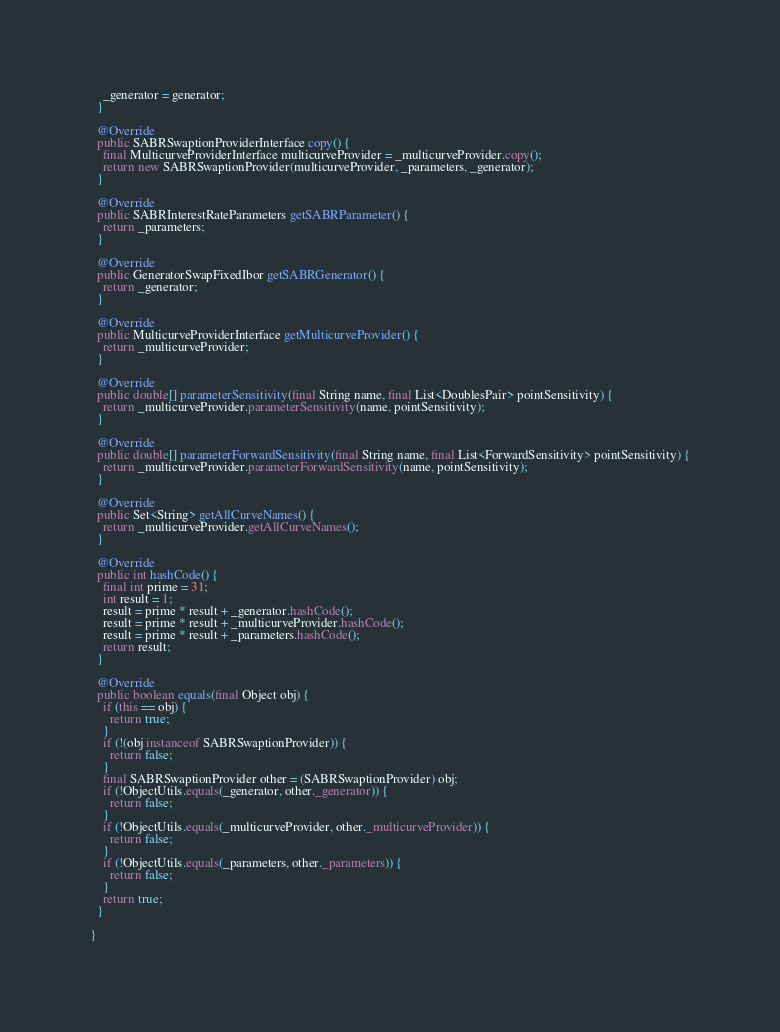<code> <loc_0><loc_0><loc_500><loc_500><_Java_>    _generator = generator;
  }

  @Override
  public SABRSwaptionProviderInterface copy() {
    final MulticurveProviderInterface multicurveProvider = _multicurveProvider.copy();
    return new SABRSwaptionProvider(multicurveProvider, _parameters, _generator);
  }

  @Override
  public SABRInterestRateParameters getSABRParameter() {
    return _parameters;
  }

  @Override
  public GeneratorSwapFixedIbor getSABRGenerator() {
    return _generator;
  }

  @Override
  public MulticurveProviderInterface getMulticurveProvider() {
    return _multicurveProvider;
  }

  @Override
  public double[] parameterSensitivity(final String name, final List<DoublesPair> pointSensitivity) {
    return _multicurveProvider.parameterSensitivity(name, pointSensitivity);
  }

  @Override
  public double[] parameterForwardSensitivity(final String name, final List<ForwardSensitivity> pointSensitivity) {
    return _multicurveProvider.parameterForwardSensitivity(name, pointSensitivity);
  }

  @Override
  public Set<String> getAllCurveNames() {
    return _multicurveProvider.getAllCurveNames();
  }

  @Override
  public int hashCode() {
    final int prime = 31;
    int result = 1;
    result = prime * result + _generator.hashCode();
    result = prime * result + _multicurveProvider.hashCode();
    result = prime * result + _parameters.hashCode();
    return result;
  }

  @Override
  public boolean equals(final Object obj) {
    if (this == obj) {
      return true;
    }
    if (!(obj instanceof SABRSwaptionProvider)) {
      return false;
    }
    final SABRSwaptionProvider other = (SABRSwaptionProvider) obj;
    if (!ObjectUtils.equals(_generator, other._generator)) {
      return false;
    }
    if (!ObjectUtils.equals(_multicurveProvider, other._multicurveProvider)) {
      return false;
    }
    if (!ObjectUtils.equals(_parameters, other._parameters)) {
      return false;
    }
    return true;
  }

}
</code> 